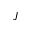Convert formula to latex. <formula><loc_0><loc_0><loc_500><loc_500>J</formula> 